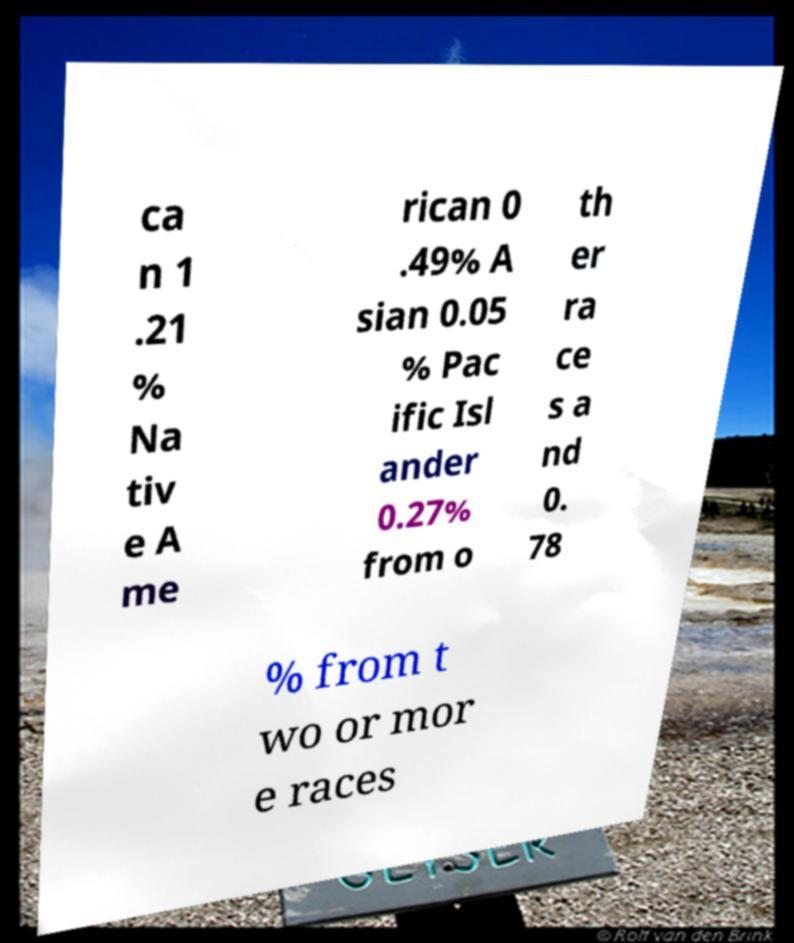Please identify and transcribe the text found in this image. ca n 1 .21 % Na tiv e A me rican 0 .49% A sian 0.05 % Pac ific Isl ander 0.27% from o th er ra ce s a nd 0. 78 % from t wo or mor e races 